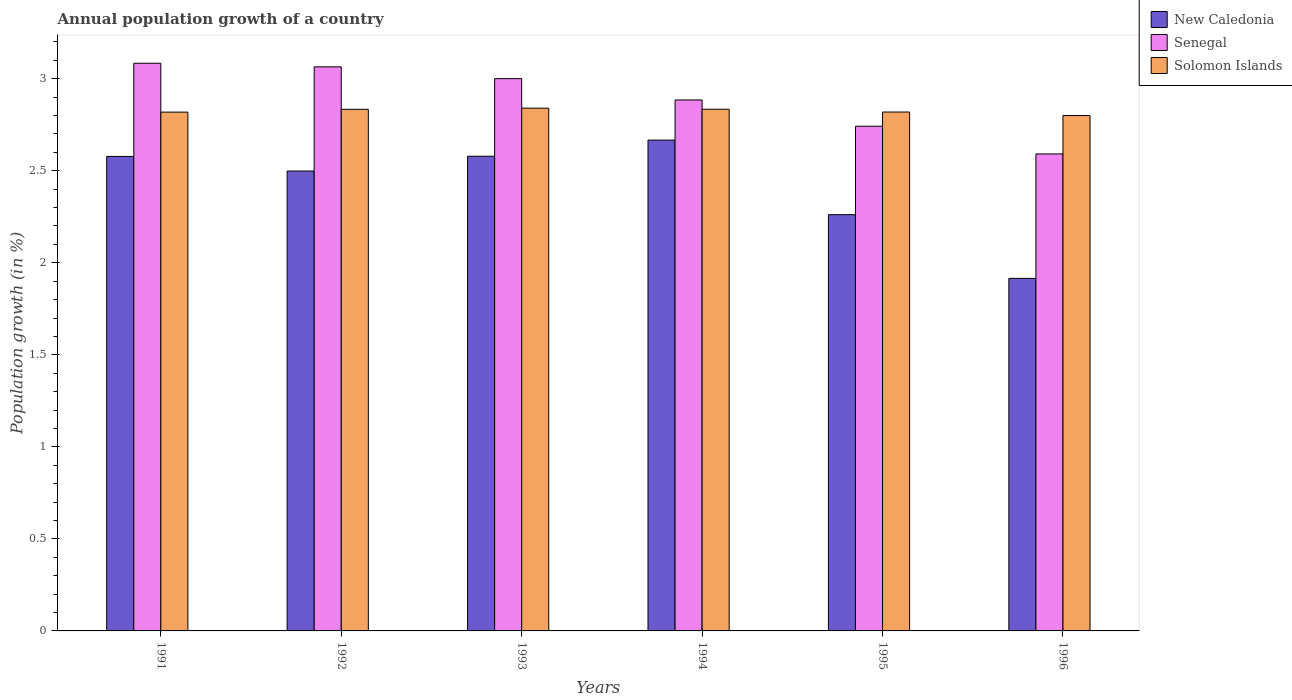How many groups of bars are there?
Your response must be concise. 6. Are the number of bars per tick equal to the number of legend labels?
Provide a succinct answer. Yes. How many bars are there on the 1st tick from the left?
Your response must be concise. 3. In how many cases, is the number of bars for a given year not equal to the number of legend labels?
Provide a succinct answer. 0. What is the annual population growth in Solomon Islands in 1991?
Ensure brevity in your answer.  2.82. Across all years, what is the maximum annual population growth in Solomon Islands?
Provide a succinct answer. 2.84. Across all years, what is the minimum annual population growth in Solomon Islands?
Offer a terse response. 2.8. In which year was the annual population growth in Senegal maximum?
Offer a terse response. 1991. In which year was the annual population growth in Solomon Islands minimum?
Provide a succinct answer. 1996. What is the total annual population growth in Senegal in the graph?
Make the answer very short. 17.37. What is the difference between the annual population growth in Senegal in 1992 and that in 1993?
Provide a succinct answer. 0.06. What is the difference between the annual population growth in Solomon Islands in 1993 and the annual population growth in Senegal in 1996?
Keep it short and to the point. 0.25. What is the average annual population growth in New Caledonia per year?
Provide a succinct answer. 2.42. In the year 1995, what is the difference between the annual population growth in New Caledonia and annual population growth in Senegal?
Your answer should be very brief. -0.48. What is the ratio of the annual population growth in Senegal in 1991 to that in 1994?
Offer a very short reply. 1.07. What is the difference between the highest and the second highest annual population growth in New Caledonia?
Provide a succinct answer. 0.09. What is the difference between the highest and the lowest annual population growth in New Caledonia?
Give a very brief answer. 0.75. In how many years, is the annual population growth in New Caledonia greater than the average annual population growth in New Caledonia taken over all years?
Offer a terse response. 4. Is the sum of the annual population growth in Senegal in 1993 and 1995 greater than the maximum annual population growth in New Caledonia across all years?
Provide a succinct answer. Yes. What does the 3rd bar from the left in 1995 represents?
Offer a terse response. Solomon Islands. What does the 3rd bar from the right in 1995 represents?
Offer a very short reply. New Caledonia. How many bars are there?
Your response must be concise. 18. Are all the bars in the graph horizontal?
Your answer should be compact. No. How many years are there in the graph?
Provide a succinct answer. 6. What is the difference between two consecutive major ticks on the Y-axis?
Make the answer very short. 0.5. Are the values on the major ticks of Y-axis written in scientific E-notation?
Keep it short and to the point. No. How are the legend labels stacked?
Make the answer very short. Vertical. What is the title of the graph?
Your answer should be very brief. Annual population growth of a country. What is the label or title of the Y-axis?
Provide a short and direct response. Population growth (in %). What is the Population growth (in %) of New Caledonia in 1991?
Keep it short and to the point. 2.58. What is the Population growth (in %) of Senegal in 1991?
Offer a very short reply. 3.08. What is the Population growth (in %) of Solomon Islands in 1991?
Make the answer very short. 2.82. What is the Population growth (in %) of New Caledonia in 1992?
Provide a succinct answer. 2.5. What is the Population growth (in %) of Senegal in 1992?
Offer a very short reply. 3.06. What is the Population growth (in %) in Solomon Islands in 1992?
Ensure brevity in your answer.  2.83. What is the Population growth (in %) of New Caledonia in 1993?
Ensure brevity in your answer.  2.58. What is the Population growth (in %) of Senegal in 1993?
Offer a very short reply. 3. What is the Population growth (in %) of Solomon Islands in 1993?
Ensure brevity in your answer.  2.84. What is the Population growth (in %) in New Caledonia in 1994?
Provide a succinct answer. 2.67. What is the Population growth (in %) of Senegal in 1994?
Your answer should be compact. 2.88. What is the Population growth (in %) in Solomon Islands in 1994?
Keep it short and to the point. 2.83. What is the Population growth (in %) in New Caledonia in 1995?
Give a very brief answer. 2.26. What is the Population growth (in %) of Senegal in 1995?
Keep it short and to the point. 2.74. What is the Population growth (in %) of Solomon Islands in 1995?
Your answer should be very brief. 2.82. What is the Population growth (in %) in New Caledonia in 1996?
Your answer should be compact. 1.92. What is the Population growth (in %) of Senegal in 1996?
Give a very brief answer. 2.59. What is the Population growth (in %) in Solomon Islands in 1996?
Give a very brief answer. 2.8. Across all years, what is the maximum Population growth (in %) of New Caledonia?
Provide a succinct answer. 2.67. Across all years, what is the maximum Population growth (in %) in Senegal?
Give a very brief answer. 3.08. Across all years, what is the maximum Population growth (in %) in Solomon Islands?
Offer a very short reply. 2.84. Across all years, what is the minimum Population growth (in %) in New Caledonia?
Ensure brevity in your answer.  1.92. Across all years, what is the minimum Population growth (in %) of Senegal?
Make the answer very short. 2.59. Across all years, what is the minimum Population growth (in %) of Solomon Islands?
Your answer should be compact. 2.8. What is the total Population growth (in %) in New Caledonia in the graph?
Offer a terse response. 14.5. What is the total Population growth (in %) in Senegal in the graph?
Keep it short and to the point. 17.37. What is the total Population growth (in %) in Solomon Islands in the graph?
Offer a very short reply. 16.95. What is the difference between the Population growth (in %) in New Caledonia in 1991 and that in 1992?
Offer a terse response. 0.08. What is the difference between the Population growth (in %) in Senegal in 1991 and that in 1992?
Give a very brief answer. 0.02. What is the difference between the Population growth (in %) in Solomon Islands in 1991 and that in 1992?
Make the answer very short. -0.02. What is the difference between the Population growth (in %) in New Caledonia in 1991 and that in 1993?
Your response must be concise. -0. What is the difference between the Population growth (in %) in Senegal in 1991 and that in 1993?
Offer a terse response. 0.08. What is the difference between the Population growth (in %) of Solomon Islands in 1991 and that in 1993?
Offer a terse response. -0.02. What is the difference between the Population growth (in %) of New Caledonia in 1991 and that in 1994?
Ensure brevity in your answer.  -0.09. What is the difference between the Population growth (in %) of Senegal in 1991 and that in 1994?
Your answer should be compact. 0.2. What is the difference between the Population growth (in %) in Solomon Islands in 1991 and that in 1994?
Give a very brief answer. -0.02. What is the difference between the Population growth (in %) of New Caledonia in 1991 and that in 1995?
Offer a very short reply. 0.32. What is the difference between the Population growth (in %) in Senegal in 1991 and that in 1995?
Give a very brief answer. 0.34. What is the difference between the Population growth (in %) in Solomon Islands in 1991 and that in 1995?
Provide a succinct answer. -0. What is the difference between the Population growth (in %) in New Caledonia in 1991 and that in 1996?
Your answer should be very brief. 0.66. What is the difference between the Population growth (in %) of Senegal in 1991 and that in 1996?
Offer a very short reply. 0.49. What is the difference between the Population growth (in %) in Solomon Islands in 1991 and that in 1996?
Offer a terse response. 0.02. What is the difference between the Population growth (in %) in New Caledonia in 1992 and that in 1993?
Keep it short and to the point. -0.08. What is the difference between the Population growth (in %) in Senegal in 1992 and that in 1993?
Make the answer very short. 0.06. What is the difference between the Population growth (in %) in Solomon Islands in 1992 and that in 1993?
Your answer should be very brief. -0.01. What is the difference between the Population growth (in %) of New Caledonia in 1992 and that in 1994?
Offer a terse response. -0.17. What is the difference between the Population growth (in %) in Senegal in 1992 and that in 1994?
Your answer should be very brief. 0.18. What is the difference between the Population growth (in %) in Solomon Islands in 1992 and that in 1994?
Give a very brief answer. -0. What is the difference between the Population growth (in %) of New Caledonia in 1992 and that in 1995?
Keep it short and to the point. 0.24. What is the difference between the Population growth (in %) of Senegal in 1992 and that in 1995?
Offer a terse response. 0.32. What is the difference between the Population growth (in %) in Solomon Islands in 1992 and that in 1995?
Make the answer very short. 0.01. What is the difference between the Population growth (in %) of New Caledonia in 1992 and that in 1996?
Offer a terse response. 0.58. What is the difference between the Population growth (in %) in Senegal in 1992 and that in 1996?
Your answer should be compact. 0.47. What is the difference between the Population growth (in %) in Solomon Islands in 1992 and that in 1996?
Your response must be concise. 0.03. What is the difference between the Population growth (in %) in New Caledonia in 1993 and that in 1994?
Keep it short and to the point. -0.09. What is the difference between the Population growth (in %) in Senegal in 1993 and that in 1994?
Keep it short and to the point. 0.12. What is the difference between the Population growth (in %) of Solomon Islands in 1993 and that in 1994?
Keep it short and to the point. 0.01. What is the difference between the Population growth (in %) of New Caledonia in 1993 and that in 1995?
Provide a succinct answer. 0.32. What is the difference between the Population growth (in %) in Senegal in 1993 and that in 1995?
Offer a very short reply. 0.26. What is the difference between the Population growth (in %) of Solomon Islands in 1993 and that in 1995?
Your answer should be very brief. 0.02. What is the difference between the Population growth (in %) of New Caledonia in 1993 and that in 1996?
Offer a terse response. 0.66. What is the difference between the Population growth (in %) of Senegal in 1993 and that in 1996?
Your response must be concise. 0.41. What is the difference between the Population growth (in %) in Solomon Islands in 1993 and that in 1996?
Your response must be concise. 0.04. What is the difference between the Population growth (in %) in New Caledonia in 1994 and that in 1995?
Provide a succinct answer. 0.41. What is the difference between the Population growth (in %) in Senegal in 1994 and that in 1995?
Make the answer very short. 0.14. What is the difference between the Population growth (in %) of Solomon Islands in 1994 and that in 1995?
Your answer should be compact. 0.02. What is the difference between the Population growth (in %) in New Caledonia in 1994 and that in 1996?
Ensure brevity in your answer.  0.75. What is the difference between the Population growth (in %) of Senegal in 1994 and that in 1996?
Make the answer very short. 0.29. What is the difference between the Population growth (in %) of Solomon Islands in 1994 and that in 1996?
Provide a short and direct response. 0.03. What is the difference between the Population growth (in %) of New Caledonia in 1995 and that in 1996?
Ensure brevity in your answer.  0.35. What is the difference between the Population growth (in %) in Senegal in 1995 and that in 1996?
Keep it short and to the point. 0.15. What is the difference between the Population growth (in %) in Solomon Islands in 1995 and that in 1996?
Ensure brevity in your answer.  0.02. What is the difference between the Population growth (in %) in New Caledonia in 1991 and the Population growth (in %) in Senegal in 1992?
Offer a terse response. -0.49. What is the difference between the Population growth (in %) of New Caledonia in 1991 and the Population growth (in %) of Solomon Islands in 1992?
Provide a succinct answer. -0.26. What is the difference between the Population growth (in %) of Senegal in 1991 and the Population growth (in %) of Solomon Islands in 1992?
Offer a terse response. 0.25. What is the difference between the Population growth (in %) of New Caledonia in 1991 and the Population growth (in %) of Senegal in 1993?
Provide a short and direct response. -0.42. What is the difference between the Population growth (in %) of New Caledonia in 1991 and the Population growth (in %) of Solomon Islands in 1993?
Make the answer very short. -0.26. What is the difference between the Population growth (in %) of Senegal in 1991 and the Population growth (in %) of Solomon Islands in 1993?
Offer a very short reply. 0.24. What is the difference between the Population growth (in %) of New Caledonia in 1991 and the Population growth (in %) of Senegal in 1994?
Make the answer very short. -0.31. What is the difference between the Population growth (in %) of New Caledonia in 1991 and the Population growth (in %) of Solomon Islands in 1994?
Your answer should be compact. -0.26. What is the difference between the Population growth (in %) in Senegal in 1991 and the Population growth (in %) in Solomon Islands in 1994?
Provide a succinct answer. 0.25. What is the difference between the Population growth (in %) in New Caledonia in 1991 and the Population growth (in %) in Senegal in 1995?
Provide a succinct answer. -0.16. What is the difference between the Population growth (in %) in New Caledonia in 1991 and the Population growth (in %) in Solomon Islands in 1995?
Your answer should be compact. -0.24. What is the difference between the Population growth (in %) of Senegal in 1991 and the Population growth (in %) of Solomon Islands in 1995?
Keep it short and to the point. 0.27. What is the difference between the Population growth (in %) in New Caledonia in 1991 and the Population growth (in %) in Senegal in 1996?
Give a very brief answer. -0.01. What is the difference between the Population growth (in %) of New Caledonia in 1991 and the Population growth (in %) of Solomon Islands in 1996?
Provide a succinct answer. -0.22. What is the difference between the Population growth (in %) of Senegal in 1991 and the Population growth (in %) of Solomon Islands in 1996?
Your answer should be very brief. 0.28. What is the difference between the Population growth (in %) of New Caledonia in 1992 and the Population growth (in %) of Senegal in 1993?
Make the answer very short. -0.5. What is the difference between the Population growth (in %) in New Caledonia in 1992 and the Population growth (in %) in Solomon Islands in 1993?
Your response must be concise. -0.34. What is the difference between the Population growth (in %) in Senegal in 1992 and the Population growth (in %) in Solomon Islands in 1993?
Your response must be concise. 0.22. What is the difference between the Population growth (in %) in New Caledonia in 1992 and the Population growth (in %) in Senegal in 1994?
Your response must be concise. -0.39. What is the difference between the Population growth (in %) of New Caledonia in 1992 and the Population growth (in %) of Solomon Islands in 1994?
Offer a terse response. -0.34. What is the difference between the Population growth (in %) in Senegal in 1992 and the Population growth (in %) in Solomon Islands in 1994?
Offer a very short reply. 0.23. What is the difference between the Population growth (in %) of New Caledonia in 1992 and the Population growth (in %) of Senegal in 1995?
Make the answer very short. -0.24. What is the difference between the Population growth (in %) in New Caledonia in 1992 and the Population growth (in %) in Solomon Islands in 1995?
Your answer should be compact. -0.32. What is the difference between the Population growth (in %) in Senegal in 1992 and the Population growth (in %) in Solomon Islands in 1995?
Provide a short and direct response. 0.25. What is the difference between the Population growth (in %) of New Caledonia in 1992 and the Population growth (in %) of Senegal in 1996?
Your answer should be compact. -0.09. What is the difference between the Population growth (in %) in New Caledonia in 1992 and the Population growth (in %) in Solomon Islands in 1996?
Offer a terse response. -0.3. What is the difference between the Population growth (in %) in Senegal in 1992 and the Population growth (in %) in Solomon Islands in 1996?
Your response must be concise. 0.26. What is the difference between the Population growth (in %) of New Caledonia in 1993 and the Population growth (in %) of Senegal in 1994?
Your answer should be compact. -0.31. What is the difference between the Population growth (in %) in New Caledonia in 1993 and the Population growth (in %) in Solomon Islands in 1994?
Provide a succinct answer. -0.26. What is the difference between the Population growth (in %) of Senegal in 1993 and the Population growth (in %) of Solomon Islands in 1994?
Your response must be concise. 0.17. What is the difference between the Population growth (in %) of New Caledonia in 1993 and the Population growth (in %) of Senegal in 1995?
Your answer should be compact. -0.16. What is the difference between the Population growth (in %) in New Caledonia in 1993 and the Population growth (in %) in Solomon Islands in 1995?
Your answer should be compact. -0.24. What is the difference between the Population growth (in %) of Senegal in 1993 and the Population growth (in %) of Solomon Islands in 1995?
Keep it short and to the point. 0.18. What is the difference between the Population growth (in %) in New Caledonia in 1993 and the Population growth (in %) in Senegal in 1996?
Make the answer very short. -0.01. What is the difference between the Population growth (in %) of New Caledonia in 1993 and the Population growth (in %) of Solomon Islands in 1996?
Give a very brief answer. -0.22. What is the difference between the Population growth (in %) in Senegal in 1993 and the Population growth (in %) in Solomon Islands in 1996?
Make the answer very short. 0.2. What is the difference between the Population growth (in %) of New Caledonia in 1994 and the Population growth (in %) of Senegal in 1995?
Offer a terse response. -0.08. What is the difference between the Population growth (in %) of New Caledonia in 1994 and the Population growth (in %) of Solomon Islands in 1995?
Offer a terse response. -0.15. What is the difference between the Population growth (in %) of Senegal in 1994 and the Population growth (in %) of Solomon Islands in 1995?
Provide a succinct answer. 0.07. What is the difference between the Population growth (in %) of New Caledonia in 1994 and the Population growth (in %) of Senegal in 1996?
Provide a succinct answer. 0.08. What is the difference between the Population growth (in %) in New Caledonia in 1994 and the Population growth (in %) in Solomon Islands in 1996?
Keep it short and to the point. -0.13. What is the difference between the Population growth (in %) of Senegal in 1994 and the Population growth (in %) of Solomon Islands in 1996?
Ensure brevity in your answer.  0.08. What is the difference between the Population growth (in %) in New Caledonia in 1995 and the Population growth (in %) in Senegal in 1996?
Your answer should be compact. -0.33. What is the difference between the Population growth (in %) of New Caledonia in 1995 and the Population growth (in %) of Solomon Islands in 1996?
Offer a terse response. -0.54. What is the difference between the Population growth (in %) of Senegal in 1995 and the Population growth (in %) of Solomon Islands in 1996?
Offer a terse response. -0.06. What is the average Population growth (in %) in New Caledonia per year?
Give a very brief answer. 2.42. What is the average Population growth (in %) of Senegal per year?
Make the answer very short. 2.89. What is the average Population growth (in %) of Solomon Islands per year?
Ensure brevity in your answer.  2.82. In the year 1991, what is the difference between the Population growth (in %) in New Caledonia and Population growth (in %) in Senegal?
Your answer should be compact. -0.51. In the year 1991, what is the difference between the Population growth (in %) of New Caledonia and Population growth (in %) of Solomon Islands?
Give a very brief answer. -0.24. In the year 1991, what is the difference between the Population growth (in %) of Senegal and Population growth (in %) of Solomon Islands?
Offer a very short reply. 0.27. In the year 1992, what is the difference between the Population growth (in %) of New Caledonia and Population growth (in %) of Senegal?
Give a very brief answer. -0.57. In the year 1992, what is the difference between the Population growth (in %) of New Caledonia and Population growth (in %) of Solomon Islands?
Provide a succinct answer. -0.34. In the year 1992, what is the difference between the Population growth (in %) in Senegal and Population growth (in %) in Solomon Islands?
Offer a very short reply. 0.23. In the year 1993, what is the difference between the Population growth (in %) of New Caledonia and Population growth (in %) of Senegal?
Your answer should be very brief. -0.42. In the year 1993, what is the difference between the Population growth (in %) of New Caledonia and Population growth (in %) of Solomon Islands?
Your response must be concise. -0.26. In the year 1993, what is the difference between the Population growth (in %) of Senegal and Population growth (in %) of Solomon Islands?
Your response must be concise. 0.16. In the year 1994, what is the difference between the Population growth (in %) of New Caledonia and Population growth (in %) of Senegal?
Make the answer very short. -0.22. In the year 1994, what is the difference between the Population growth (in %) of New Caledonia and Population growth (in %) of Solomon Islands?
Offer a terse response. -0.17. In the year 1994, what is the difference between the Population growth (in %) in Senegal and Population growth (in %) in Solomon Islands?
Provide a short and direct response. 0.05. In the year 1995, what is the difference between the Population growth (in %) in New Caledonia and Population growth (in %) in Senegal?
Your response must be concise. -0.48. In the year 1995, what is the difference between the Population growth (in %) in New Caledonia and Population growth (in %) in Solomon Islands?
Give a very brief answer. -0.56. In the year 1995, what is the difference between the Population growth (in %) of Senegal and Population growth (in %) of Solomon Islands?
Your response must be concise. -0.08. In the year 1996, what is the difference between the Population growth (in %) in New Caledonia and Population growth (in %) in Senegal?
Provide a succinct answer. -0.68. In the year 1996, what is the difference between the Population growth (in %) of New Caledonia and Population growth (in %) of Solomon Islands?
Your answer should be very brief. -0.89. In the year 1996, what is the difference between the Population growth (in %) in Senegal and Population growth (in %) in Solomon Islands?
Make the answer very short. -0.21. What is the ratio of the Population growth (in %) of New Caledonia in 1991 to that in 1992?
Make the answer very short. 1.03. What is the ratio of the Population growth (in %) of New Caledonia in 1991 to that in 1993?
Give a very brief answer. 1. What is the ratio of the Population growth (in %) in Senegal in 1991 to that in 1993?
Your response must be concise. 1.03. What is the ratio of the Population growth (in %) of Solomon Islands in 1991 to that in 1993?
Provide a short and direct response. 0.99. What is the ratio of the Population growth (in %) of New Caledonia in 1991 to that in 1994?
Give a very brief answer. 0.97. What is the ratio of the Population growth (in %) of Senegal in 1991 to that in 1994?
Your answer should be very brief. 1.07. What is the ratio of the Population growth (in %) of Solomon Islands in 1991 to that in 1994?
Provide a succinct answer. 0.99. What is the ratio of the Population growth (in %) in New Caledonia in 1991 to that in 1995?
Offer a terse response. 1.14. What is the ratio of the Population growth (in %) of Senegal in 1991 to that in 1995?
Give a very brief answer. 1.12. What is the ratio of the Population growth (in %) in New Caledonia in 1991 to that in 1996?
Make the answer very short. 1.35. What is the ratio of the Population growth (in %) in Senegal in 1991 to that in 1996?
Offer a very short reply. 1.19. What is the ratio of the Population growth (in %) in New Caledonia in 1992 to that in 1993?
Keep it short and to the point. 0.97. What is the ratio of the Population growth (in %) in Senegal in 1992 to that in 1993?
Your answer should be compact. 1.02. What is the ratio of the Population growth (in %) in New Caledonia in 1992 to that in 1994?
Your response must be concise. 0.94. What is the ratio of the Population growth (in %) of Senegal in 1992 to that in 1994?
Provide a succinct answer. 1.06. What is the ratio of the Population growth (in %) in Solomon Islands in 1992 to that in 1994?
Provide a succinct answer. 1. What is the ratio of the Population growth (in %) in New Caledonia in 1992 to that in 1995?
Provide a short and direct response. 1.1. What is the ratio of the Population growth (in %) in Senegal in 1992 to that in 1995?
Give a very brief answer. 1.12. What is the ratio of the Population growth (in %) in Solomon Islands in 1992 to that in 1995?
Offer a very short reply. 1.01. What is the ratio of the Population growth (in %) in New Caledonia in 1992 to that in 1996?
Offer a terse response. 1.3. What is the ratio of the Population growth (in %) in Senegal in 1992 to that in 1996?
Provide a short and direct response. 1.18. What is the ratio of the Population growth (in %) in Solomon Islands in 1992 to that in 1996?
Make the answer very short. 1.01. What is the ratio of the Population growth (in %) in New Caledonia in 1993 to that in 1994?
Give a very brief answer. 0.97. What is the ratio of the Population growth (in %) in Senegal in 1993 to that in 1994?
Offer a very short reply. 1.04. What is the ratio of the Population growth (in %) in New Caledonia in 1993 to that in 1995?
Provide a short and direct response. 1.14. What is the ratio of the Population growth (in %) of Senegal in 1993 to that in 1995?
Keep it short and to the point. 1.09. What is the ratio of the Population growth (in %) in Solomon Islands in 1993 to that in 1995?
Offer a terse response. 1.01. What is the ratio of the Population growth (in %) in New Caledonia in 1993 to that in 1996?
Give a very brief answer. 1.35. What is the ratio of the Population growth (in %) in Senegal in 1993 to that in 1996?
Your answer should be compact. 1.16. What is the ratio of the Population growth (in %) of Solomon Islands in 1993 to that in 1996?
Ensure brevity in your answer.  1.01. What is the ratio of the Population growth (in %) of New Caledonia in 1994 to that in 1995?
Ensure brevity in your answer.  1.18. What is the ratio of the Population growth (in %) in Senegal in 1994 to that in 1995?
Make the answer very short. 1.05. What is the ratio of the Population growth (in %) in Solomon Islands in 1994 to that in 1995?
Provide a succinct answer. 1.01. What is the ratio of the Population growth (in %) of New Caledonia in 1994 to that in 1996?
Keep it short and to the point. 1.39. What is the ratio of the Population growth (in %) of Senegal in 1994 to that in 1996?
Provide a succinct answer. 1.11. What is the ratio of the Population growth (in %) in Solomon Islands in 1994 to that in 1996?
Provide a short and direct response. 1.01. What is the ratio of the Population growth (in %) in New Caledonia in 1995 to that in 1996?
Provide a succinct answer. 1.18. What is the ratio of the Population growth (in %) of Senegal in 1995 to that in 1996?
Provide a short and direct response. 1.06. What is the difference between the highest and the second highest Population growth (in %) in New Caledonia?
Give a very brief answer. 0.09. What is the difference between the highest and the second highest Population growth (in %) of Senegal?
Ensure brevity in your answer.  0.02. What is the difference between the highest and the second highest Population growth (in %) in Solomon Islands?
Offer a very short reply. 0.01. What is the difference between the highest and the lowest Population growth (in %) in New Caledonia?
Give a very brief answer. 0.75. What is the difference between the highest and the lowest Population growth (in %) of Senegal?
Make the answer very short. 0.49. What is the difference between the highest and the lowest Population growth (in %) of Solomon Islands?
Provide a succinct answer. 0.04. 